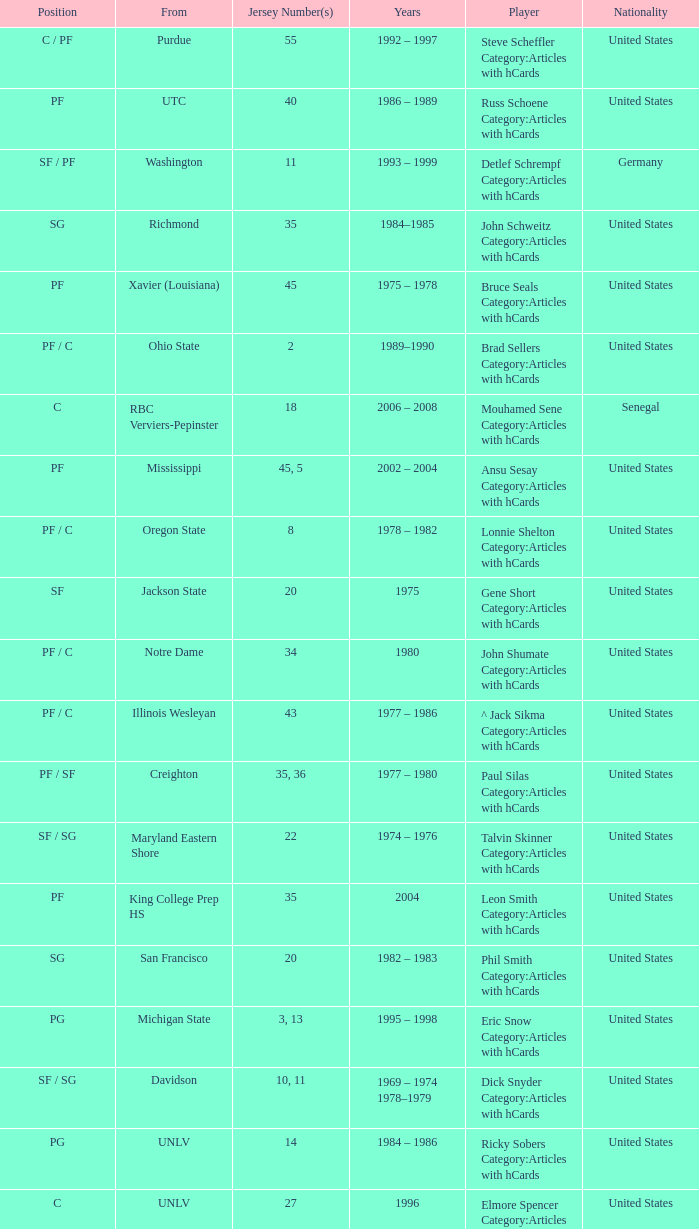What position does the player with jersey number 22 play? SF / SG. 